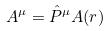<formula> <loc_0><loc_0><loc_500><loc_500>A ^ { \mu } = \hat { P } ^ { \mu } A ( r )</formula> 